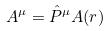<formula> <loc_0><loc_0><loc_500><loc_500>A ^ { \mu } = \hat { P } ^ { \mu } A ( r )</formula> 